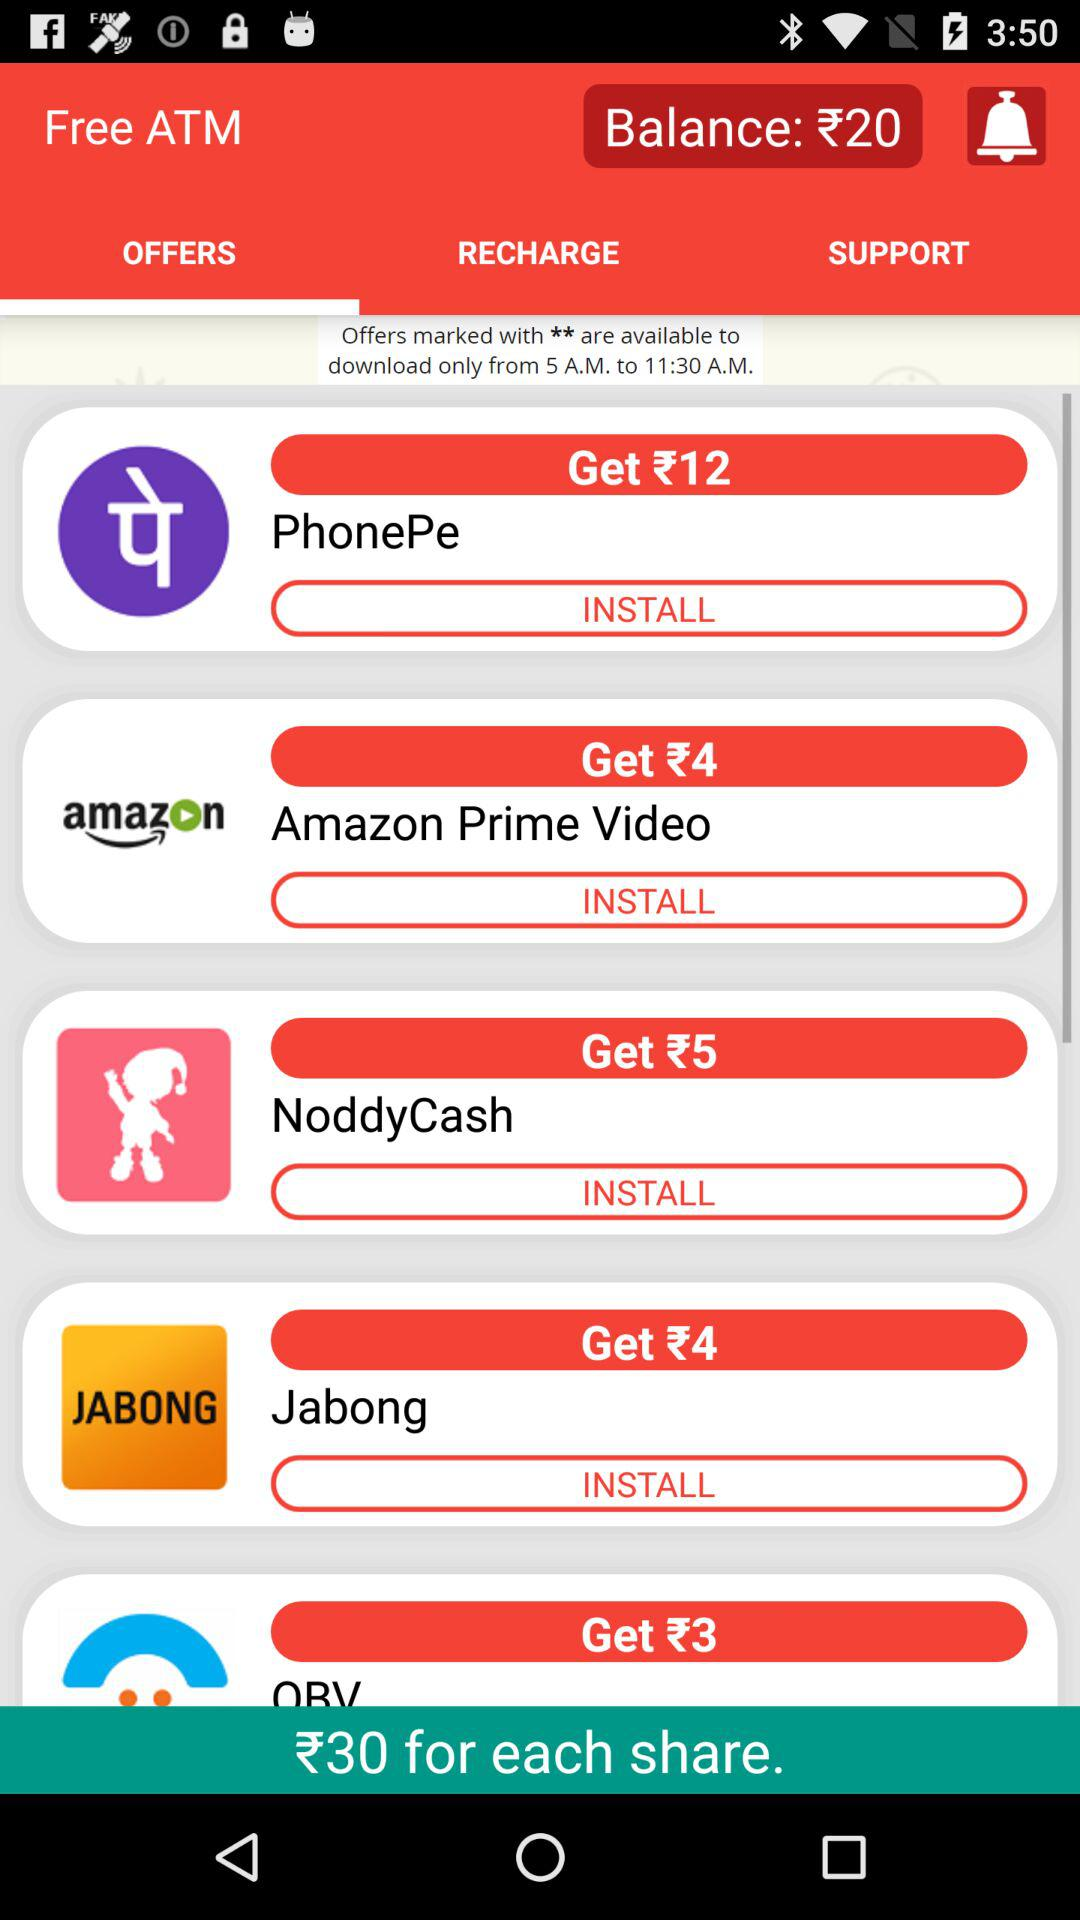How much are we earning by sharing? You are earning ₹30 by sharing. 